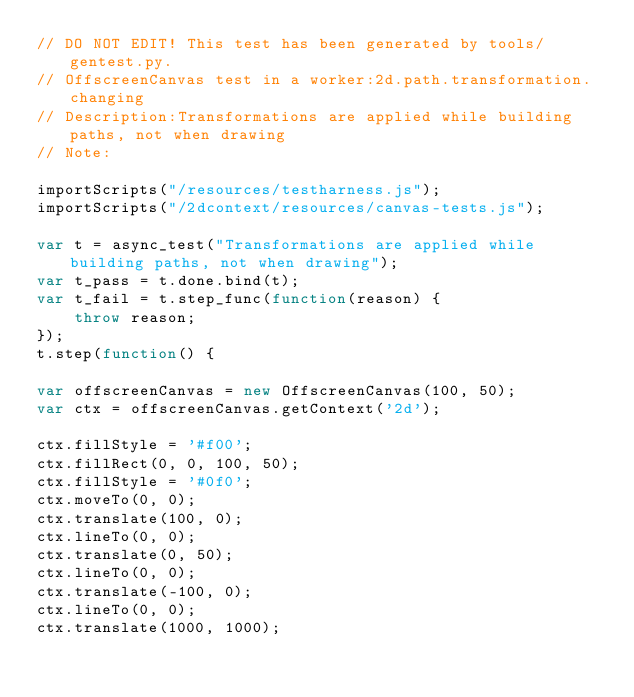<code> <loc_0><loc_0><loc_500><loc_500><_JavaScript_>// DO NOT EDIT! This test has been generated by tools/gentest.py.
// OffscreenCanvas test in a worker:2d.path.transformation.changing
// Description:Transformations are applied while building paths, not when drawing
// Note:

importScripts("/resources/testharness.js");
importScripts("/2dcontext/resources/canvas-tests.js");

var t = async_test("Transformations are applied while building paths, not when drawing");
var t_pass = t.done.bind(t);
var t_fail = t.step_func(function(reason) {
    throw reason;
});
t.step(function() {

var offscreenCanvas = new OffscreenCanvas(100, 50);
var ctx = offscreenCanvas.getContext('2d');

ctx.fillStyle = '#f00';
ctx.fillRect(0, 0, 100, 50);
ctx.fillStyle = '#0f0';
ctx.moveTo(0, 0);
ctx.translate(100, 0);
ctx.lineTo(0, 0);
ctx.translate(0, 50);
ctx.lineTo(0, 0);
ctx.translate(-100, 0);
ctx.lineTo(0, 0);
ctx.translate(1000, 1000);</code> 